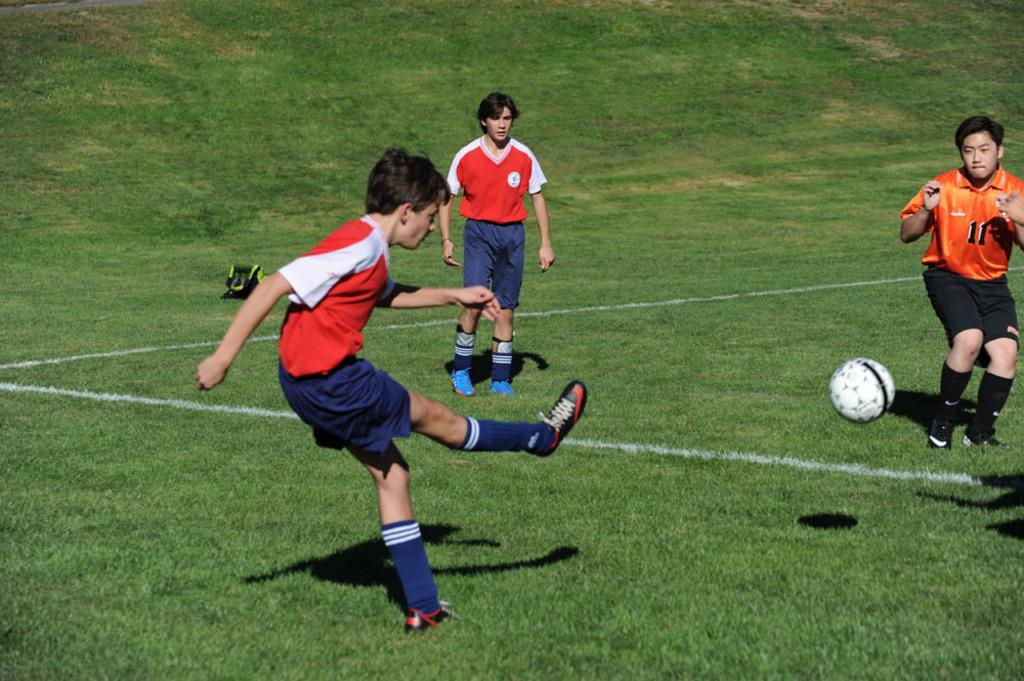What is the main subject of the image? The main subject of the image is the boys. What are the boys doing in the image? The boys are playing in the image. What type of environment is visible in the image? There is grassland around the area of the image. How many trees can be seen in the image? There are no trees visible in the image; it features boys playing on grassland. What type of animal is present in the image? There is no animal present in the image; it features boys playing on grassland. 